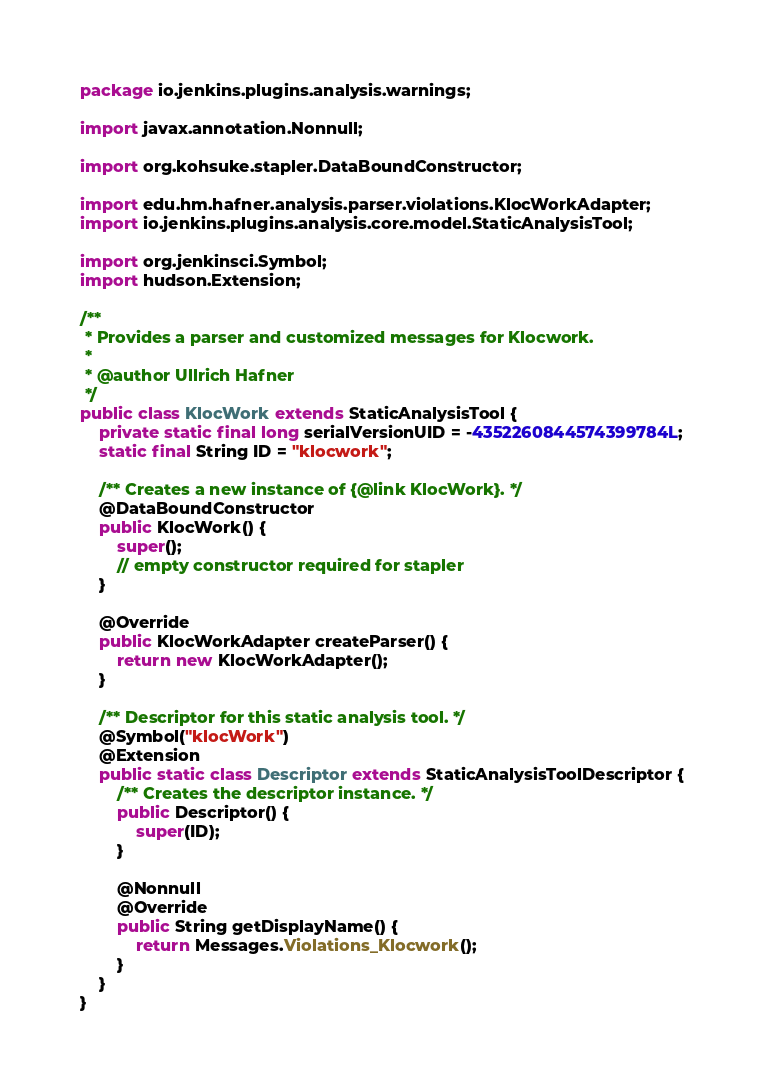<code> <loc_0><loc_0><loc_500><loc_500><_Java_>package io.jenkins.plugins.analysis.warnings;

import javax.annotation.Nonnull;

import org.kohsuke.stapler.DataBoundConstructor;

import edu.hm.hafner.analysis.parser.violations.KlocWorkAdapter;
import io.jenkins.plugins.analysis.core.model.StaticAnalysisTool;

import org.jenkinsci.Symbol;
import hudson.Extension;

/**
 * Provides a parser and customized messages for Klocwork.
 *
 * @author Ullrich Hafner
 */
public class KlocWork extends StaticAnalysisTool {
    private static final long serialVersionUID = -4352260844574399784L;
    static final String ID = "klocwork";

    /** Creates a new instance of {@link KlocWork}. */
    @DataBoundConstructor
    public KlocWork() {
        super();
        // empty constructor required for stapler
    }

    @Override
    public KlocWorkAdapter createParser() {
        return new KlocWorkAdapter();
    }

    /** Descriptor for this static analysis tool. */
    @Symbol("klocWork")
    @Extension
    public static class Descriptor extends StaticAnalysisToolDescriptor {
        /** Creates the descriptor instance. */
        public Descriptor() {
            super(ID);
        }

        @Nonnull
        @Override
        public String getDisplayName() {
            return Messages.Violations_Klocwork();
        }
    }
}
</code> 